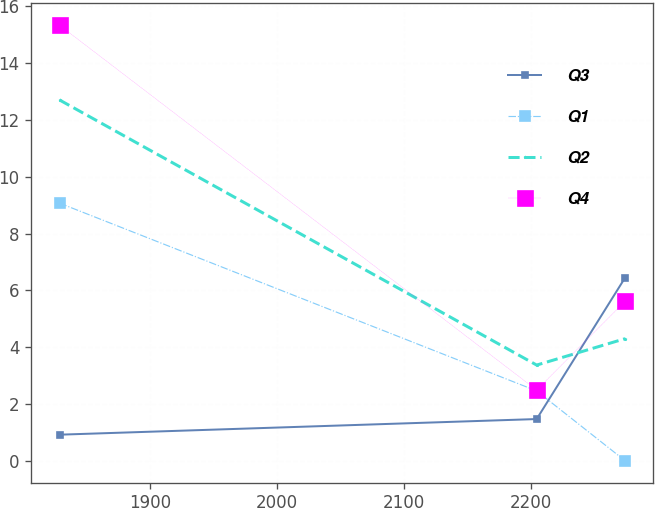Convert chart to OTSL. <chart><loc_0><loc_0><loc_500><loc_500><line_chart><ecel><fcel>Q3<fcel>Q1<fcel>Q2<fcel>Q4<nl><fcel>1828.92<fcel>0.92<fcel>9.07<fcel>12.7<fcel>15.33<nl><fcel>2204.52<fcel>1.47<fcel>2.46<fcel>3.37<fcel>2.49<nl><fcel>2274.19<fcel>6.45<fcel>0<fcel>4.3<fcel>5.62<nl></chart> 